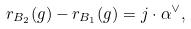Convert formula to latex. <formula><loc_0><loc_0><loc_500><loc_500>r _ { B _ { 2 } } ( g ) - r _ { B _ { 1 } } ( g ) = j \cdot \alpha ^ { \vee } ,</formula> 